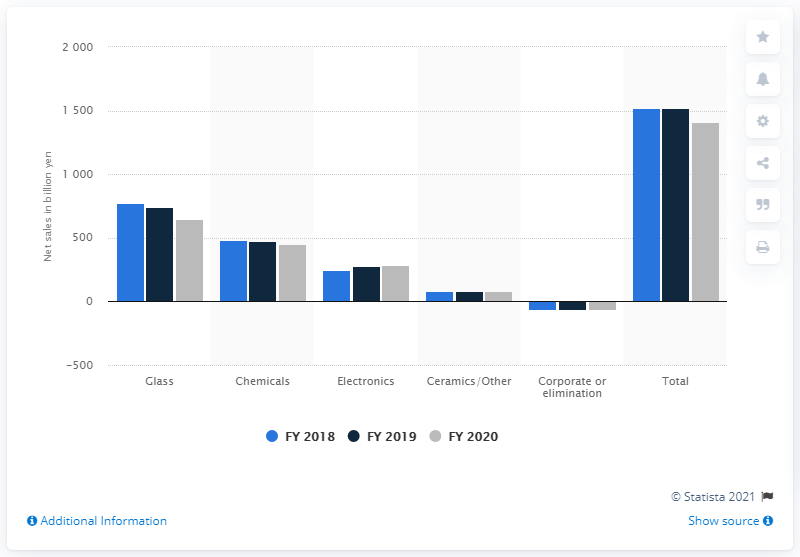Outline some significant characteristics in this image. The net sales of AGC in 2020 were 1412.3. In 2020, the net sales of AGC Inc's glass sector amounted to 651. 